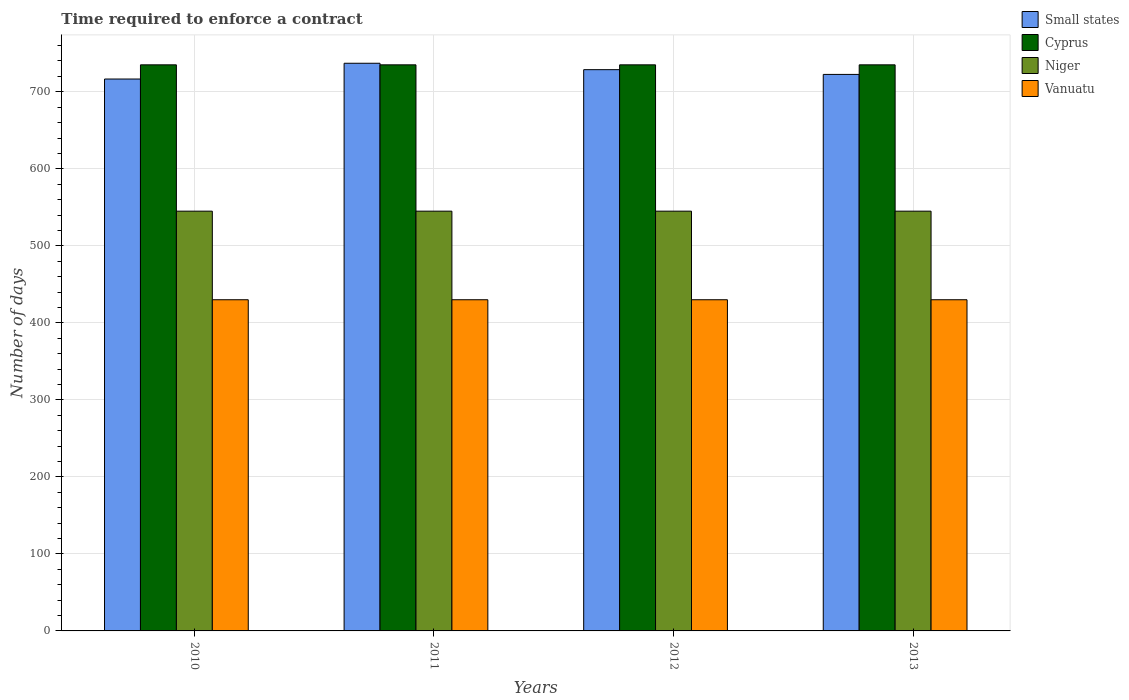Are the number of bars per tick equal to the number of legend labels?
Your answer should be very brief. Yes. In how many cases, is the number of bars for a given year not equal to the number of legend labels?
Your answer should be very brief. 0. What is the number of days required to enforce a contract in Niger in 2013?
Offer a very short reply. 545. Across all years, what is the maximum number of days required to enforce a contract in Cyprus?
Ensure brevity in your answer.  735. Across all years, what is the minimum number of days required to enforce a contract in Cyprus?
Offer a terse response. 735. In which year was the number of days required to enforce a contract in Small states maximum?
Your answer should be very brief. 2011. In which year was the number of days required to enforce a contract in Niger minimum?
Make the answer very short. 2010. What is the total number of days required to enforce a contract in Vanuatu in the graph?
Offer a terse response. 1720. What is the difference between the number of days required to enforce a contract in Vanuatu in 2010 and the number of days required to enforce a contract in Niger in 2013?
Give a very brief answer. -115. What is the average number of days required to enforce a contract in Cyprus per year?
Provide a short and direct response. 735. In the year 2013, what is the difference between the number of days required to enforce a contract in Vanuatu and number of days required to enforce a contract in Small states?
Your response must be concise. -292.58. In how many years, is the number of days required to enforce a contract in Cyprus greater than 600 days?
Your answer should be compact. 4. What is the difference between the highest and the second highest number of days required to enforce a contract in Niger?
Your answer should be compact. 0. Is the sum of the number of days required to enforce a contract in Vanuatu in 2012 and 2013 greater than the maximum number of days required to enforce a contract in Cyprus across all years?
Give a very brief answer. Yes. What does the 1st bar from the left in 2013 represents?
Make the answer very short. Small states. What does the 3rd bar from the right in 2010 represents?
Provide a short and direct response. Cyprus. Is it the case that in every year, the sum of the number of days required to enforce a contract in Niger and number of days required to enforce a contract in Cyprus is greater than the number of days required to enforce a contract in Vanuatu?
Your answer should be compact. Yes. What is the difference between two consecutive major ticks on the Y-axis?
Make the answer very short. 100. Does the graph contain grids?
Make the answer very short. Yes. Where does the legend appear in the graph?
Your answer should be compact. Top right. How many legend labels are there?
Offer a very short reply. 4. How are the legend labels stacked?
Your answer should be compact. Vertical. What is the title of the graph?
Keep it short and to the point. Time required to enforce a contract. What is the label or title of the X-axis?
Make the answer very short. Years. What is the label or title of the Y-axis?
Your answer should be compact. Number of days. What is the Number of days of Small states in 2010?
Your response must be concise. 716.59. What is the Number of days in Cyprus in 2010?
Offer a terse response. 735. What is the Number of days in Niger in 2010?
Provide a succinct answer. 545. What is the Number of days in Vanuatu in 2010?
Your answer should be very brief. 430. What is the Number of days of Small states in 2011?
Provide a short and direct response. 737.05. What is the Number of days in Cyprus in 2011?
Make the answer very short. 735. What is the Number of days of Niger in 2011?
Offer a terse response. 545. What is the Number of days in Vanuatu in 2011?
Your answer should be compact. 430. What is the Number of days in Small states in 2012?
Make the answer very short. 728.73. What is the Number of days of Cyprus in 2012?
Provide a short and direct response. 735. What is the Number of days in Niger in 2012?
Ensure brevity in your answer.  545. What is the Number of days of Vanuatu in 2012?
Provide a succinct answer. 430. What is the Number of days of Small states in 2013?
Your response must be concise. 722.58. What is the Number of days of Cyprus in 2013?
Offer a terse response. 735. What is the Number of days of Niger in 2013?
Offer a very short reply. 545. What is the Number of days in Vanuatu in 2013?
Offer a terse response. 430. Across all years, what is the maximum Number of days in Small states?
Your answer should be very brief. 737.05. Across all years, what is the maximum Number of days in Cyprus?
Your answer should be very brief. 735. Across all years, what is the maximum Number of days of Niger?
Keep it short and to the point. 545. Across all years, what is the maximum Number of days of Vanuatu?
Offer a terse response. 430. Across all years, what is the minimum Number of days of Small states?
Offer a very short reply. 716.59. Across all years, what is the minimum Number of days of Cyprus?
Provide a short and direct response. 735. Across all years, what is the minimum Number of days of Niger?
Give a very brief answer. 545. Across all years, what is the minimum Number of days in Vanuatu?
Provide a short and direct response. 430. What is the total Number of days in Small states in the graph?
Your answer should be very brief. 2904.94. What is the total Number of days of Cyprus in the graph?
Provide a succinct answer. 2940. What is the total Number of days of Niger in the graph?
Offer a terse response. 2180. What is the total Number of days of Vanuatu in the graph?
Give a very brief answer. 1720. What is the difference between the Number of days in Small states in 2010 and that in 2011?
Give a very brief answer. -20.46. What is the difference between the Number of days of Cyprus in 2010 and that in 2011?
Provide a succinct answer. 0. What is the difference between the Number of days of Small states in 2010 and that in 2012?
Offer a terse response. -12.14. What is the difference between the Number of days in Cyprus in 2010 and that in 2012?
Offer a very short reply. 0. What is the difference between the Number of days of Niger in 2010 and that in 2012?
Provide a short and direct response. 0. What is the difference between the Number of days of Small states in 2010 and that in 2013?
Offer a terse response. -5.99. What is the difference between the Number of days in Cyprus in 2010 and that in 2013?
Provide a short and direct response. 0. What is the difference between the Number of days in Niger in 2010 and that in 2013?
Keep it short and to the point. 0. What is the difference between the Number of days in Small states in 2011 and that in 2012?
Offer a very short reply. 8.32. What is the difference between the Number of days of Cyprus in 2011 and that in 2012?
Offer a terse response. 0. What is the difference between the Number of days of Niger in 2011 and that in 2012?
Your answer should be very brief. 0. What is the difference between the Number of days of Small states in 2011 and that in 2013?
Offer a terse response. 14.47. What is the difference between the Number of days in Cyprus in 2011 and that in 2013?
Your answer should be compact. 0. What is the difference between the Number of days of Vanuatu in 2011 and that in 2013?
Your answer should be very brief. 0. What is the difference between the Number of days in Small states in 2012 and that in 2013?
Ensure brevity in your answer.  6.15. What is the difference between the Number of days of Niger in 2012 and that in 2013?
Your answer should be very brief. 0. What is the difference between the Number of days of Vanuatu in 2012 and that in 2013?
Provide a short and direct response. 0. What is the difference between the Number of days of Small states in 2010 and the Number of days of Cyprus in 2011?
Your answer should be very brief. -18.41. What is the difference between the Number of days of Small states in 2010 and the Number of days of Niger in 2011?
Ensure brevity in your answer.  171.59. What is the difference between the Number of days of Small states in 2010 and the Number of days of Vanuatu in 2011?
Provide a succinct answer. 286.59. What is the difference between the Number of days in Cyprus in 2010 and the Number of days in Niger in 2011?
Keep it short and to the point. 190. What is the difference between the Number of days of Cyprus in 2010 and the Number of days of Vanuatu in 2011?
Your response must be concise. 305. What is the difference between the Number of days in Niger in 2010 and the Number of days in Vanuatu in 2011?
Offer a very short reply. 115. What is the difference between the Number of days in Small states in 2010 and the Number of days in Cyprus in 2012?
Your answer should be compact. -18.41. What is the difference between the Number of days of Small states in 2010 and the Number of days of Niger in 2012?
Your response must be concise. 171.59. What is the difference between the Number of days of Small states in 2010 and the Number of days of Vanuatu in 2012?
Give a very brief answer. 286.59. What is the difference between the Number of days of Cyprus in 2010 and the Number of days of Niger in 2012?
Make the answer very short. 190. What is the difference between the Number of days of Cyprus in 2010 and the Number of days of Vanuatu in 2012?
Give a very brief answer. 305. What is the difference between the Number of days in Niger in 2010 and the Number of days in Vanuatu in 2012?
Provide a succinct answer. 115. What is the difference between the Number of days in Small states in 2010 and the Number of days in Cyprus in 2013?
Provide a succinct answer. -18.41. What is the difference between the Number of days in Small states in 2010 and the Number of days in Niger in 2013?
Provide a short and direct response. 171.59. What is the difference between the Number of days in Small states in 2010 and the Number of days in Vanuatu in 2013?
Provide a short and direct response. 286.59. What is the difference between the Number of days of Cyprus in 2010 and the Number of days of Niger in 2013?
Your response must be concise. 190. What is the difference between the Number of days in Cyprus in 2010 and the Number of days in Vanuatu in 2013?
Give a very brief answer. 305. What is the difference between the Number of days of Niger in 2010 and the Number of days of Vanuatu in 2013?
Give a very brief answer. 115. What is the difference between the Number of days in Small states in 2011 and the Number of days in Cyprus in 2012?
Offer a very short reply. 2.05. What is the difference between the Number of days of Small states in 2011 and the Number of days of Niger in 2012?
Offer a terse response. 192.05. What is the difference between the Number of days of Small states in 2011 and the Number of days of Vanuatu in 2012?
Offer a terse response. 307.05. What is the difference between the Number of days in Cyprus in 2011 and the Number of days in Niger in 2012?
Give a very brief answer. 190. What is the difference between the Number of days of Cyprus in 2011 and the Number of days of Vanuatu in 2012?
Your response must be concise. 305. What is the difference between the Number of days in Niger in 2011 and the Number of days in Vanuatu in 2012?
Offer a very short reply. 115. What is the difference between the Number of days of Small states in 2011 and the Number of days of Cyprus in 2013?
Offer a terse response. 2.05. What is the difference between the Number of days in Small states in 2011 and the Number of days in Niger in 2013?
Your answer should be very brief. 192.05. What is the difference between the Number of days in Small states in 2011 and the Number of days in Vanuatu in 2013?
Provide a short and direct response. 307.05. What is the difference between the Number of days of Cyprus in 2011 and the Number of days of Niger in 2013?
Ensure brevity in your answer.  190. What is the difference between the Number of days of Cyprus in 2011 and the Number of days of Vanuatu in 2013?
Your response must be concise. 305. What is the difference between the Number of days in Niger in 2011 and the Number of days in Vanuatu in 2013?
Provide a succinct answer. 115. What is the difference between the Number of days of Small states in 2012 and the Number of days of Cyprus in 2013?
Offer a terse response. -6.28. What is the difference between the Number of days of Small states in 2012 and the Number of days of Niger in 2013?
Give a very brief answer. 183.72. What is the difference between the Number of days in Small states in 2012 and the Number of days in Vanuatu in 2013?
Offer a very short reply. 298.73. What is the difference between the Number of days in Cyprus in 2012 and the Number of days in Niger in 2013?
Offer a very short reply. 190. What is the difference between the Number of days in Cyprus in 2012 and the Number of days in Vanuatu in 2013?
Your answer should be very brief. 305. What is the difference between the Number of days of Niger in 2012 and the Number of days of Vanuatu in 2013?
Your answer should be very brief. 115. What is the average Number of days of Small states per year?
Ensure brevity in your answer.  726.23. What is the average Number of days of Cyprus per year?
Provide a succinct answer. 735. What is the average Number of days of Niger per year?
Provide a short and direct response. 545. What is the average Number of days of Vanuatu per year?
Keep it short and to the point. 430. In the year 2010, what is the difference between the Number of days of Small states and Number of days of Cyprus?
Give a very brief answer. -18.41. In the year 2010, what is the difference between the Number of days of Small states and Number of days of Niger?
Your answer should be very brief. 171.59. In the year 2010, what is the difference between the Number of days of Small states and Number of days of Vanuatu?
Give a very brief answer. 286.59. In the year 2010, what is the difference between the Number of days of Cyprus and Number of days of Niger?
Offer a terse response. 190. In the year 2010, what is the difference between the Number of days of Cyprus and Number of days of Vanuatu?
Offer a very short reply. 305. In the year 2010, what is the difference between the Number of days in Niger and Number of days in Vanuatu?
Ensure brevity in your answer.  115. In the year 2011, what is the difference between the Number of days in Small states and Number of days in Cyprus?
Offer a very short reply. 2.05. In the year 2011, what is the difference between the Number of days of Small states and Number of days of Niger?
Keep it short and to the point. 192.05. In the year 2011, what is the difference between the Number of days in Small states and Number of days in Vanuatu?
Make the answer very short. 307.05. In the year 2011, what is the difference between the Number of days of Cyprus and Number of days of Niger?
Give a very brief answer. 190. In the year 2011, what is the difference between the Number of days in Cyprus and Number of days in Vanuatu?
Make the answer very short. 305. In the year 2011, what is the difference between the Number of days in Niger and Number of days in Vanuatu?
Offer a terse response. 115. In the year 2012, what is the difference between the Number of days of Small states and Number of days of Cyprus?
Provide a succinct answer. -6.28. In the year 2012, what is the difference between the Number of days in Small states and Number of days in Niger?
Provide a short and direct response. 183.72. In the year 2012, what is the difference between the Number of days of Small states and Number of days of Vanuatu?
Keep it short and to the point. 298.73. In the year 2012, what is the difference between the Number of days in Cyprus and Number of days in Niger?
Offer a terse response. 190. In the year 2012, what is the difference between the Number of days in Cyprus and Number of days in Vanuatu?
Offer a terse response. 305. In the year 2012, what is the difference between the Number of days of Niger and Number of days of Vanuatu?
Your response must be concise. 115. In the year 2013, what is the difference between the Number of days in Small states and Number of days in Cyprus?
Ensure brevity in your answer.  -12.43. In the year 2013, what is the difference between the Number of days in Small states and Number of days in Niger?
Make the answer very short. 177.57. In the year 2013, what is the difference between the Number of days of Small states and Number of days of Vanuatu?
Your response must be concise. 292.57. In the year 2013, what is the difference between the Number of days of Cyprus and Number of days of Niger?
Your response must be concise. 190. In the year 2013, what is the difference between the Number of days in Cyprus and Number of days in Vanuatu?
Ensure brevity in your answer.  305. In the year 2013, what is the difference between the Number of days of Niger and Number of days of Vanuatu?
Provide a short and direct response. 115. What is the ratio of the Number of days of Small states in 2010 to that in 2011?
Your answer should be very brief. 0.97. What is the ratio of the Number of days of Cyprus in 2010 to that in 2011?
Make the answer very short. 1. What is the ratio of the Number of days in Niger in 2010 to that in 2011?
Give a very brief answer. 1. What is the ratio of the Number of days in Small states in 2010 to that in 2012?
Make the answer very short. 0.98. What is the ratio of the Number of days in Vanuatu in 2010 to that in 2012?
Your response must be concise. 1. What is the ratio of the Number of days of Small states in 2010 to that in 2013?
Make the answer very short. 0.99. What is the ratio of the Number of days in Cyprus in 2010 to that in 2013?
Offer a terse response. 1. What is the ratio of the Number of days of Vanuatu in 2010 to that in 2013?
Provide a succinct answer. 1. What is the ratio of the Number of days in Small states in 2011 to that in 2012?
Offer a very short reply. 1.01. What is the ratio of the Number of days of Cyprus in 2011 to that in 2012?
Offer a very short reply. 1. What is the ratio of the Number of days of Small states in 2011 to that in 2013?
Your response must be concise. 1.02. What is the ratio of the Number of days in Cyprus in 2011 to that in 2013?
Your answer should be very brief. 1. What is the ratio of the Number of days in Niger in 2011 to that in 2013?
Provide a short and direct response. 1. What is the ratio of the Number of days of Small states in 2012 to that in 2013?
Keep it short and to the point. 1.01. What is the ratio of the Number of days of Cyprus in 2012 to that in 2013?
Provide a succinct answer. 1. What is the difference between the highest and the second highest Number of days in Small states?
Your answer should be compact. 8.32. What is the difference between the highest and the second highest Number of days in Cyprus?
Keep it short and to the point. 0. What is the difference between the highest and the second highest Number of days of Niger?
Provide a succinct answer. 0. What is the difference between the highest and the lowest Number of days of Small states?
Keep it short and to the point. 20.46. 